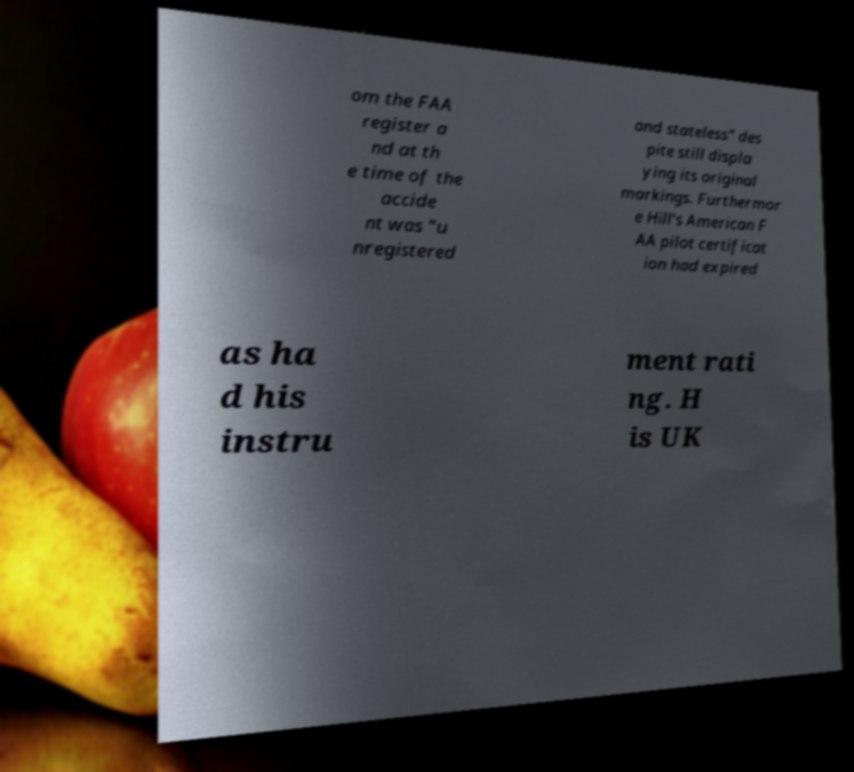For documentation purposes, I need the text within this image transcribed. Could you provide that? om the FAA register a nd at th e time of the accide nt was "u nregistered and stateless" des pite still displa ying its original markings. Furthermor e Hill's American F AA pilot certificat ion had expired as ha d his instru ment rati ng. H is UK 